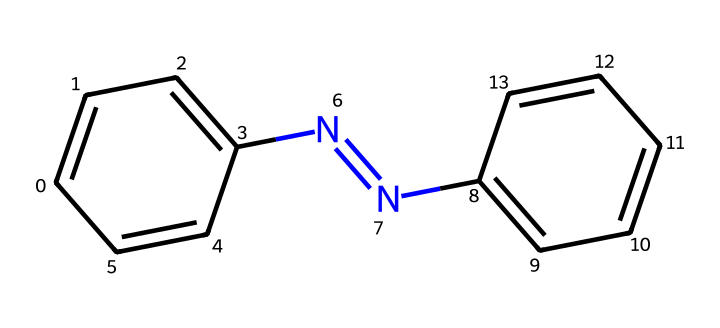What is the molecular formula of azobenzene? To determine the molecular formula, count the total number of each type of atom present in the compound based on its structure. There are 12 carbon atoms, 10 hydrogen atoms, and 2 nitrogen atoms. Therefore, the molecular formula is C12H10N2.
Answer: C12H10N2 How many double bonds are present in azobenzene? Inspect the structure to identify the presence of double bonds. There are two N=N double bonds, and each aromatic ring has alternating double bonds as part of their structure, leading to a total of 6 double bonds (4 from the benzene rings and 2 from the azo group). So, the total number of double bonds is 6.
Answer: 6 What is the functional group present in azobenzene? By analyzing the structure, the functional group is identified as the azo group (N=N), which is responsible for its photoreactive properties.
Answer: azo group What type of isomerism is exhibited by azobenzene? Azobenzene exhibits cis-trans isomerism due to the ability of the azo group to switch between its two isomeric forms (cis and trans) when exposed to light.
Answer: cis-trans isomerism What role does azobenzene play in photoreactive applications? The unique characteristic of azobenzene to switch its structure upon light exposure allows it to function as a photoswitchable dye, making it applicable in photonic devices and smart materials.
Answer: photoswitchable dye How many rings are present in the azobenzene structure? Analyze the structure for rings. There are two benzene rings in the azobenzene molecule, one on each side of the azo group.
Answer: 2 